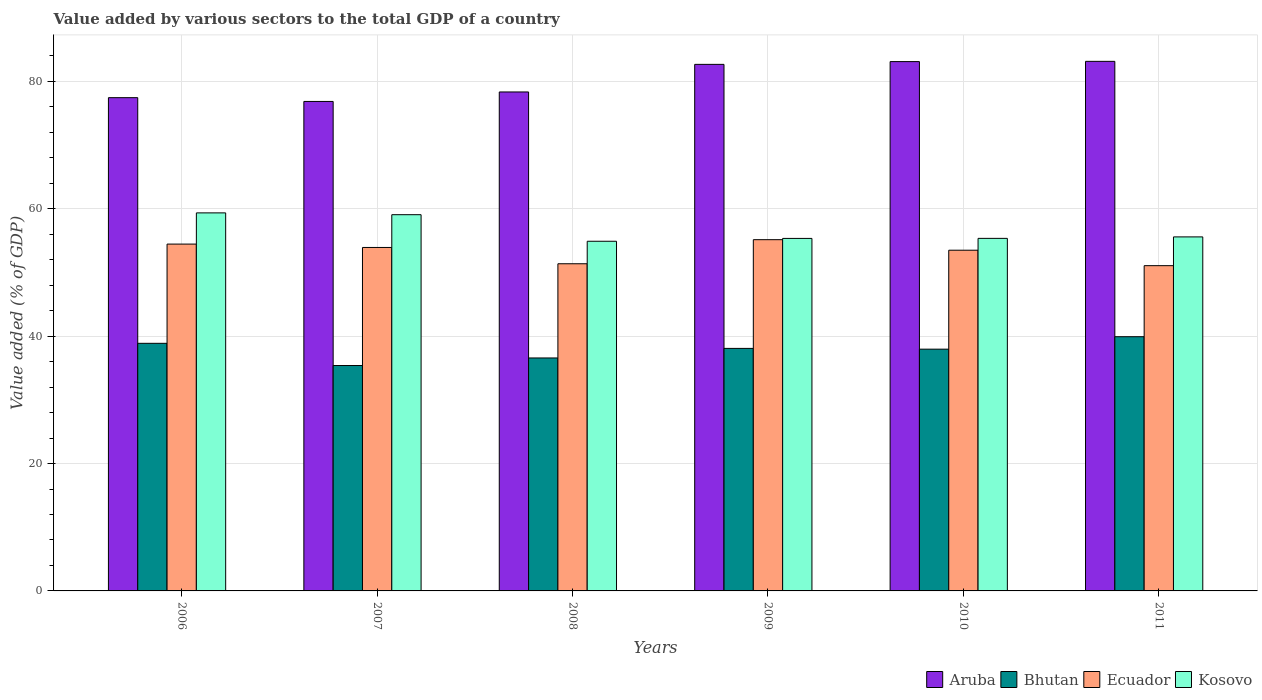Are the number of bars on each tick of the X-axis equal?
Provide a succinct answer. Yes. In how many cases, is the number of bars for a given year not equal to the number of legend labels?
Provide a succinct answer. 0. What is the value added by various sectors to the total GDP in Bhutan in 2008?
Make the answer very short. 36.58. Across all years, what is the maximum value added by various sectors to the total GDP in Bhutan?
Provide a short and direct response. 39.92. Across all years, what is the minimum value added by various sectors to the total GDP in Bhutan?
Provide a short and direct response. 35.39. In which year was the value added by various sectors to the total GDP in Kosovo maximum?
Your response must be concise. 2006. What is the total value added by various sectors to the total GDP in Ecuador in the graph?
Offer a terse response. 319.49. What is the difference between the value added by various sectors to the total GDP in Bhutan in 2006 and that in 2009?
Provide a succinct answer. 0.8. What is the difference between the value added by various sectors to the total GDP in Bhutan in 2008 and the value added by various sectors to the total GDP in Kosovo in 2006?
Provide a succinct answer. -22.78. What is the average value added by various sectors to the total GDP in Bhutan per year?
Provide a short and direct response. 37.8. In the year 2010, what is the difference between the value added by various sectors to the total GDP in Bhutan and value added by various sectors to the total GDP in Ecuador?
Give a very brief answer. -15.54. What is the ratio of the value added by various sectors to the total GDP in Aruba in 2007 to that in 2010?
Give a very brief answer. 0.92. Is the difference between the value added by various sectors to the total GDP in Bhutan in 2008 and 2010 greater than the difference between the value added by various sectors to the total GDP in Ecuador in 2008 and 2010?
Keep it short and to the point. Yes. What is the difference between the highest and the second highest value added by various sectors to the total GDP in Ecuador?
Keep it short and to the point. 0.69. What is the difference between the highest and the lowest value added by various sectors to the total GDP in Aruba?
Offer a terse response. 6.3. What does the 1st bar from the left in 2010 represents?
Your answer should be compact. Aruba. What does the 2nd bar from the right in 2009 represents?
Your answer should be compact. Ecuador. Is it the case that in every year, the sum of the value added by various sectors to the total GDP in Aruba and value added by various sectors to the total GDP in Ecuador is greater than the value added by various sectors to the total GDP in Bhutan?
Offer a terse response. Yes. How many bars are there?
Your response must be concise. 24. Are all the bars in the graph horizontal?
Your answer should be compact. No. How many years are there in the graph?
Give a very brief answer. 6. Does the graph contain any zero values?
Provide a short and direct response. No. How are the legend labels stacked?
Your answer should be compact. Horizontal. What is the title of the graph?
Provide a short and direct response. Value added by various sectors to the total GDP of a country. What is the label or title of the Y-axis?
Offer a very short reply. Value added (% of GDP). What is the Value added (% of GDP) in Aruba in 2006?
Your response must be concise. 77.45. What is the Value added (% of GDP) in Bhutan in 2006?
Your answer should be compact. 38.88. What is the Value added (% of GDP) in Ecuador in 2006?
Offer a terse response. 54.46. What is the Value added (% of GDP) of Kosovo in 2006?
Your answer should be compact. 59.36. What is the Value added (% of GDP) of Aruba in 2007?
Your response must be concise. 76.86. What is the Value added (% of GDP) of Bhutan in 2007?
Provide a succinct answer. 35.39. What is the Value added (% of GDP) in Ecuador in 2007?
Keep it short and to the point. 53.93. What is the Value added (% of GDP) in Kosovo in 2007?
Keep it short and to the point. 59.08. What is the Value added (% of GDP) in Aruba in 2008?
Your response must be concise. 78.35. What is the Value added (% of GDP) in Bhutan in 2008?
Ensure brevity in your answer.  36.58. What is the Value added (% of GDP) of Ecuador in 2008?
Provide a succinct answer. 51.37. What is the Value added (% of GDP) of Kosovo in 2008?
Ensure brevity in your answer.  54.91. What is the Value added (% of GDP) of Aruba in 2009?
Offer a terse response. 82.68. What is the Value added (% of GDP) in Bhutan in 2009?
Your answer should be very brief. 38.08. What is the Value added (% of GDP) in Ecuador in 2009?
Offer a terse response. 55.15. What is the Value added (% of GDP) in Kosovo in 2009?
Your answer should be very brief. 55.35. What is the Value added (% of GDP) of Aruba in 2010?
Give a very brief answer. 83.12. What is the Value added (% of GDP) of Bhutan in 2010?
Give a very brief answer. 37.96. What is the Value added (% of GDP) of Ecuador in 2010?
Provide a succinct answer. 53.5. What is the Value added (% of GDP) in Kosovo in 2010?
Your response must be concise. 55.36. What is the Value added (% of GDP) in Aruba in 2011?
Ensure brevity in your answer.  83.16. What is the Value added (% of GDP) in Bhutan in 2011?
Provide a short and direct response. 39.92. What is the Value added (% of GDP) of Ecuador in 2011?
Offer a terse response. 51.07. What is the Value added (% of GDP) in Kosovo in 2011?
Make the answer very short. 55.59. Across all years, what is the maximum Value added (% of GDP) in Aruba?
Keep it short and to the point. 83.16. Across all years, what is the maximum Value added (% of GDP) of Bhutan?
Make the answer very short. 39.92. Across all years, what is the maximum Value added (% of GDP) of Ecuador?
Make the answer very short. 55.15. Across all years, what is the maximum Value added (% of GDP) of Kosovo?
Offer a terse response. 59.36. Across all years, what is the minimum Value added (% of GDP) in Aruba?
Offer a very short reply. 76.86. Across all years, what is the minimum Value added (% of GDP) of Bhutan?
Make the answer very short. 35.39. Across all years, what is the minimum Value added (% of GDP) of Ecuador?
Ensure brevity in your answer.  51.07. Across all years, what is the minimum Value added (% of GDP) of Kosovo?
Provide a succinct answer. 54.91. What is the total Value added (% of GDP) of Aruba in the graph?
Your response must be concise. 481.62. What is the total Value added (% of GDP) in Bhutan in the graph?
Provide a short and direct response. 226.81. What is the total Value added (% of GDP) of Ecuador in the graph?
Offer a terse response. 319.49. What is the total Value added (% of GDP) in Kosovo in the graph?
Provide a succinct answer. 339.65. What is the difference between the Value added (% of GDP) in Aruba in 2006 and that in 2007?
Offer a terse response. 0.59. What is the difference between the Value added (% of GDP) of Bhutan in 2006 and that in 2007?
Give a very brief answer. 3.49. What is the difference between the Value added (% of GDP) of Ecuador in 2006 and that in 2007?
Your answer should be very brief. 0.53. What is the difference between the Value added (% of GDP) of Kosovo in 2006 and that in 2007?
Give a very brief answer. 0.28. What is the difference between the Value added (% of GDP) of Aruba in 2006 and that in 2008?
Your answer should be compact. -0.9. What is the difference between the Value added (% of GDP) of Bhutan in 2006 and that in 2008?
Provide a short and direct response. 2.3. What is the difference between the Value added (% of GDP) in Ecuador in 2006 and that in 2008?
Make the answer very short. 3.09. What is the difference between the Value added (% of GDP) of Kosovo in 2006 and that in 2008?
Your answer should be very brief. 4.46. What is the difference between the Value added (% of GDP) of Aruba in 2006 and that in 2009?
Provide a short and direct response. -5.23. What is the difference between the Value added (% of GDP) in Bhutan in 2006 and that in 2009?
Provide a succinct answer. 0.8. What is the difference between the Value added (% of GDP) in Ecuador in 2006 and that in 2009?
Your response must be concise. -0.69. What is the difference between the Value added (% of GDP) in Kosovo in 2006 and that in 2009?
Your response must be concise. 4.01. What is the difference between the Value added (% of GDP) of Aruba in 2006 and that in 2010?
Offer a very short reply. -5.66. What is the difference between the Value added (% of GDP) in Bhutan in 2006 and that in 2010?
Offer a very short reply. 0.92. What is the difference between the Value added (% of GDP) in Ecuador in 2006 and that in 2010?
Give a very brief answer. 0.96. What is the difference between the Value added (% of GDP) in Kosovo in 2006 and that in 2010?
Your response must be concise. 4. What is the difference between the Value added (% of GDP) of Aruba in 2006 and that in 2011?
Your answer should be very brief. -5.7. What is the difference between the Value added (% of GDP) of Bhutan in 2006 and that in 2011?
Offer a very short reply. -1.04. What is the difference between the Value added (% of GDP) in Ecuador in 2006 and that in 2011?
Make the answer very short. 3.39. What is the difference between the Value added (% of GDP) in Kosovo in 2006 and that in 2011?
Provide a short and direct response. 3.77. What is the difference between the Value added (% of GDP) in Aruba in 2007 and that in 2008?
Your answer should be very brief. -1.49. What is the difference between the Value added (% of GDP) in Bhutan in 2007 and that in 2008?
Make the answer very short. -1.19. What is the difference between the Value added (% of GDP) in Ecuador in 2007 and that in 2008?
Your response must be concise. 2.56. What is the difference between the Value added (% of GDP) of Kosovo in 2007 and that in 2008?
Offer a very short reply. 4.17. What is the difference between the Value added (% of GDP) of Aruba in 2007 and that in 2009?
Provide a succinct answer. -5.82. What is the difference between the Value added (% of GDP) of Bhutan in 2007 and that in 2009?
Your answer should be compact. -2.69. What is the difference between the Value added (% of GDP) in Ecuador in 2007 and that in 2009?
Provide a short and direct response. -1.22. What is the difference between the Value added (% of GDP) of Kosovo in 2007 and that in 2009?
Ensure brevity in your answer.  3.73. What is the difference between the Value added (% of GDP) of Aruba in 2007 and that in 2010?
Provide a succinct answer. -6.26. What is the difference between the Value added (% of GDP) in Bhutan in 2007 and that in 2010?
Give a very brief answer. -2.57. What is the difference between the Value added (% of GDP) in Ecuador in 2007 and that in 2010?
Keep it short and to the point. 0.43. What is the difference between the Value added (% of GDP) in Kosovo in 2007 and that in 2010?
Keep it short and to the point. 3.72. What is the difference between the Value added (% of GDP) of Aruba in 2007 and that in 2011?
Offer a very short reply. -6.3. What is the difference between the Value added (% of GDP) of Bhutan in 2007 and that in 2011?
Keep it short and to the point. -4.53. What is the difference between the Value added (% of GDP) in Ecuador in 2007 and that in 2011?
Your answer should be very brief. 2.86. What is the difference between the Value added (% of GDP) in Kosovo in 2007 and that in 2011?
Provide a short and direct response. 3.49. What is the difference between the Value added (% of GDP) of Aruba in 2008 and that in 2009?
Ensure brevity in your answer.  -4.33. What is the difference between the Value added (% of GDP) in Bhutan in 2008 and that in 2009?
Offer a very short reply. -1.5. What is the difference between the Value added (% of GDP) of Ecuador in 2008 and that in 2009?
Give a very brief answer. -3.78. What is the difference between the Value added (% of GDP) of Kosovo in 2008 and that in 2009?
Your response must be concise. -0.45. What is the difference between the Value added (% of GDP) of Aruba in 2008 and that in 2010?
Offer a very short reply. -4.77. What is the difference between the Value added (% of GDP) of Bhutan in 2008 and that in 2010?
Ensure brevity in your answer.  -1.38. What is the difference between the Value added (% of GDP) of Ecuador in 2008 and that in 2010?
Keep it short and to the point. -2.13. What is the difference between the Value added (% of GDP) in Kosovo in 2008 and that in 2010?
Provide a short and direct response. -0.45. What is the difference between the Value added (% of GDP) of Aruba in 2008 and that in 2011?
Your answer should be compact. -4.81. What is the difference between the Value added (% of GDP) of Bhutan in 2008 and that in 2011?
Ensure brevity in your answer.  -3.34. What is the difference between the Value added (% of GDP) in Ecuador in 2008 and that in 2011?
Offer a terse response. 0.3. What is the difference between the Value added (% of GDP) in Kosovo in 2008 and that in 2011?
Your answer should be compact. -0.68. What is the difference between the Value added (% of GDP) of Aruba in 2009 and that in 2010?
Offer a terse response. -0.44. What is the difference between the Value added (% of GDP) of Bhutan in 2009 and that in 2010?
Provide a succinct answer. 0.12. What is the difference between the Value added (% of GDP) in Ecuador in 2009 and that in 2010?
Your answer should be very brief. 1.65. What is the difference between the Value added (% of GDP) of Kosovo in 2009 and that in 2010?
Provide a short and direct response. -0.01. What is the difference between the Value added (% of GDP) of Aruba in 2009 and that in 2011?
Your answer should be very brief. -0.47. What is the difference between the Value added (% of GDP) in Bhutan in 2009 and that in 2011?
Offer a terse response. -1.83. What is the difference between the Value added (% of GDP) of Ecuador in 2009 and that in 2011?
Offer a terse response. 4.08. What is the difference between the Value added (% of GDP) of Kosovo in 2009 and that in 2011?
Your answer should be very brief. -0.24. What is the difference between the Value added (% of GDP) in Aruba in 2010 and that in 2011?
Provide a succinct answer. -0.04. What is the difference between the Value added (% of GDP) in Bhutan in 2010 and that in 2011?
Provide a succinct answer. -1.96. What is the difference between the Value added (% of GDP) in Ecuador in 2010 and that in 2011?
Make the answer very short. 2.43. What is the difference between the Value added (% of GDP) of Kosovo in 2010 and that in 2011?
Keep it short and to the point. -0.23. What is the difference between the Value added (% of GDP) of Aruba in 2006 and the Value added (% of GDP) of Bhutan in 2007?
Give a very brief answer. 42.06. What is the difference between the Value added (% of GDP) in Aruba in 2006 and the Value added (% of GDP) in Ecuador in 2007?
Provide a short and direct response. 23.52. What is the difference between the Value added (% of GDP) of Aruba in 2006 and the Value added (% of GDP) of Kosovo in 2007?
Your answer should be compact. 18.37. What is the difference between the Value added (% of GDP) of Bhutan in 2006 and the Value added (% of GDP) of Ecuador in 2007?
Give a very brief answer. -15.05. What is the difference between the Value added (% of GDP) of Bhutan in 2006 and the Value added (% of GDP) of Kosovo in 2007?
Ensure brevity in your answer.  -20.2. What is the difference between the Value added (% of GDP) in Ecuador in 2006 and the Value added (% of GDP) in Kosovo in 2007?
Offer a very short reply. -4.62. What is the difference between the Value added (% of GDP) in Aruba in 2006 and the Value added (% of GDP) in Bhutan in 2008?
Your answer should be very brief. 40.87. What is the difference between the Value added (% of GDP) of Aruba in 2006 and the Value added (% of GDP) of Ecuador in 2008?
Your answer should be compact. 26.08. What is the difference between the Value added (% of GDP) of Aruba in 2006 and the Value added (% of GDP) of Kosovo in 2008?
Offer a very short reply. 22.55. What is the difference between the Value added (% of GDP) in Bhutan in 2006 and the Value added (% of GDP) in Ecuador in 2008?
Give a very brief answer. -12.49. What is the difference between the Value added (% of GDP) of Bhutan in 2006 and the Value added (% of GDP) of Kosovo in 2008?
Provide a short and direct response. -16.03. What is the difference between the Value added (% of GDP) of Ecuador in 2006 and the Value added (% of GDP) of Kosovo in 2008?
Your answer should be very brief. -0.44. What is the difference between the Value added (% of GDP) in Aruba in 2006 and the Value added (% of GDP) in Bhutan in 2009?
Give a very brief answer. 39.37. What is the difference between the Value added (% of GDP) of Aruba in 2006 and the Value added (% of GDP) of Ecuador in 2009?
Your response must be concise. 22.3. What is the difference between the Value added (% of GDP) in Aruba in 2006 and the Value added (% of GDP) in Kosovo in 2009?
Your answer should be compact. 22.1. What is the difference between the Value added (% of GDP) in Bhutan in 2006 and the Value added (% of GDP) in Ecuador in 2009?
Your answer should be very brief. -16.27. What is the difference between the Value added (% of GDP) of Bhutan in 2006 and the Value added (% of GDP) of Kosovo in 2009?
Ensure brevity in your answer.  -16.47. What is the difference between the Value added (% of GDP) of Ecuador in 2006 and the Value added (% of GDP) of Kosovo in 2009?
Your answer should be compact. -0.89. What is the difference between the Value added (% of GDP) of Aruba in 2006 and the Value added (% of GDP) of Bhutan in 2010?
Your answer should be very brief. 39.49. What is the difference between the Value added (% of GDP) of Aruba in 2006 and the Value added (% of GDP) of Ecuador in 2010?
Provide a short and direct response. 23.95. What is the difference between the Value added (% of GDP) of Aruba in 2006 and the Value added (% of GDP) of Kosovo in 2010?
Keep it short and to the point. 22.09. What is the difference between the Value added (% of GDP) of Bhutan in 2006 and the Value added (% of GDP) of Ecuador in 2010?
Provide a succinct answer. -14.62. What is the difference between the Value added (% of GDP) of Bhutan in 2006 and the Value added (% of GDP) of Kosovo in 2010?
Ensure brevity in your answer.  -16.48. What is the difference between the Value added (% of GDP) in Ecuador in 2006 and the Value added (% of GDP) in Kosovo in 2010?
Ensure brevity in your answer.  -0.9. What is the difference between the Value added (% of GDP) in Aruba in 2006 and the Value added (% of GDP) in Bhutan in 2011?
Make the answer very short. 37.54. What is the difference between the Value added (% of GDP) of Aruba in 2006 and the Value added (% of GDP) of Ecuador in 2011?
Give a very brief answer. 26.38. What is the difference between the Value added (% of GDP) in Aruba in 2006 and the Value added (% of GDP) in Kosovo in 2011?
Your answer should be very brief. 21.86. What is the difference between the Value added (% of GDP) of Bhutan in 2006 and the Value added (% of GDP) of Ecuador in 2011?
Your answer should be compact. -12.19. What is the difference between the Value added (% of GDP) in Bhutan in 2006 and the Value added (% of GDP) in Kosovo in 2011?
Your answer should be compact. -16.71. What is the difference between the Value added (% of GDP) of Ecuador in 2006 and the Value added (% of GDP) of Kosovo in 2011?
Make the answer very short. -1.13. What is the difference between the Value added (% of GDP) in Aruba in 2007 and the Value added (% of GDP) in Bhutan in 2008?
Provide a succinct answer. 40.28. What is the difference between the Value added (% of GDP) in Aruba in 2007 and the Value added (% of GDP) in Ecuador in 2008?
Your answer should be compact. 25.49. What is the difference between the Value added (% of GDP) of Aruba in 2007 and the Value added (% of GDP) of Kosovo in 2008?
Give a very brief answer. 21.95. What is the difference between the Value added (% of GDP) of Bhutan in 2007 and the Value added (% of GDP) of Ecuador in 2008?
Offer a very short reply. -15.98. What is the difference between the Value added (% of GDP) of Bhutan in 2007 and the Value added (% of GDP) of Kosovo in 2008?
Your answer should be compact. -19.51. What is the difference between the Value added (% of GDP) of Ecuador in 2007 and the Value added (% of GDP) of Kosovo in 2008?
Offer a very short reply. -0.98. What is the difference between the Value added (% of GDP) of Aruba in 2007 and the Value added (% of GDP) of Bhutan in 2009?
Keep it short and to the point. 38.78. What is the difference between the Value added (% of GDP) of Aruba in 2007 and the Value added (% of GDP) of Ecuador in 2009?
Offer a very short reply. 21.71. What is the difference between the Value added (% of GDP) of Aruba in 2007 and the Value added (% of GDP) of Kosovo in 2009?
Make the answer very short. 21.51. What is the difference between the Value added (% of GDP) of Bhutan in 2007 and the Value added (% of GDP) of Ecuador in 2009?
Offer a very short reply. -19.76. What is the difference between the Value added (% of GDP) of Bhutan in 2007 and the Value added (% of GDP) of Kosovo in 2009?
Make the answer very short. -19.96. What is the difference between the Value added (% of GDP) in Ecuador in 2007 and the Value added (% of GDP) in Kosovo in 2009?
Your response must be concise. -1.42. What is the difference between the Value added (% of GDP) in Aruba in 2007 and the Value added (% of GDP) in Bhutan in 2010?
Your answer should be compact. 38.9. What is the difference between the Value added (% of GDP) in Aruba in 2007 and the Value added (% of GDP) in Ecuador in 2010?
Your answer should be very brief. 23.36. What is the difference between the Value added (% of GDP) in Aruba in 2007 and the Value added (% of GDP) in Kosovo in 2010?
Offer a very short reply. 21.5. What is the difference between the Value added (% of GDP) in Bhutan in 2007 and the Value added (% of GDP) in Ecuador in 2010?
Make the answer very short. -18.11. What is the difference between the Value added (% of GDP) in Bhutan in 2007 and the Value added (% of GDP) in Kosovo in 2010?
Your answer should be very brief. -19.97. What is the difference between the Value added (% of GDP) of Ecuador in 2007 and the Value added (% of GDP) of Kosovo in 2010?
Ensure brevity in your answer.  -1.43. What is the difference between the Value added (% of GDP) of Aruba in 2007 and the Value added (% of GDP) of Bhutan in 2011?
Ensure brevity in your answer.  36.94. What is the difference between the Value added (% of GDP) in Aruba in 2007 and the Value added (% of GDP) in Ecuador in 2011?
Give a very brief answer. 25.79. What is the difference between the Value added (% of GDP) in Aruba in 2007 and the Value added (% of GDP) in Kosovo in 2011?
Provide a short and direct response. 21.27. What is the difference between the Value added (% of GDP) in Bhutan in 2007 and the Value added (% of GDP) in Ecuador in 2011?
Offer a very short reply. -15.68. What is the difference between the Value added (% of GDP) of Bhutan in 2007 and the Value added (% of GDP) of Kosovo in 2011?
Offer a very short reply. -20.2. What is the difference between the Value added (% of GDP) in Ecuador in 2007 and the Value added (% of GDP) in Kosovo in 2011?
Your answer should be compact. -1.66. What is the difference between the Value added (% of GDP) in Aruba in 2008 and the Value added (% of GDP) in Bhutan in 2009?
Offer a terse response. 40.27. What is the difference between the Value added (% of GDP) of Aruba in 2008 and the Value added (% of GDP) of Ecuador in 2009?
Keep it short and to the point. 23.2. What is the difference between the Value added (% of GDP) in Aruba in 2008 and the Value added (% of GDP) in Kosovo in 2009?
Your answer should be very brief. 23. What is the difference between the Value added (% of GDP) in Bhutan in 2008 and the Value added (% of GDP) in Ecuador in 2009?
Provide a short and direct response. -18.57. What is the difference between the Value added (% of GDP) in Bhutan in 2008 and the Value added (% of GDP) in Kosovo in 2009?
Your answer should be very brief. -18.77. What is the difference between the Value added (% of GDP) of Ecuador in 2008 and the Value added (% of GDP) of Kosovo in 2009?
Your answer should be compact. -3.98. What is the difference between the Value added (% of GDP) of Aruba in 2008 and the Value added (% of GDP) of Bhutan in 2010?
Provide a short and direct response. 40.39. What is the difference between the Value added (% of GDP) of Aruba in 2008 and the Value added (% of GDP) of Ecuador in 2010?
Offer a very short reply. 24.85. What is the difference between the Value added (% of GDP) of Aruba in 2008 and the Value added (% of GDP) of Kosovo in 2010?
Your response must be concise. 22.99. What is the difference between the Value added (% of GDP) of Bhutan in 2008 and the Value added (% of GDP) of Ecuador in 2010?
Keep it short and to the point. -16.92. What is the difference between the Value added (% of GDP) in Bhutan in 2008 and the Value added (% of GDP) in Kosovo in 2010?
Keep it short and to the point. -18.78. What is the difference between the Value added (% of GDP) of Ecuador in 2008 and the Value added (% of GDP) of Kosovo in 2010?
Your answer should be compact. -3.99. What is the difference between the Value added (% of GDP) in Aruba in 2008 and the Value added (% of GDP) in Bhutan in 2011?
Keep it short and to the point. 38.43. What is the difference between the Value added (% of GDP) in Aruba in 2008 and the Value added (% of GDP) in Ecuador in 2011?
Make the answer very short. 27.28. What is the difference between the Value added (% of GDP) of Aruba in 2008 and the Value added (% of GDP) of Kosovo in 2011?
Your response must be concise. 22.76. What is the difference between the Value added (% of GDP) in Bhutan in 2008 and the Value added (% of GDP) in Ecuador in 2011?
Give a very brief answer. -14.49. What is the difference between the Value added (% of GDP) of Bhutan in 2008 and the Value added (% of GDP) of Kosovo in 2011?
Give a very brief answer. -19.01. What is the difference between the Value added (% of GDP) of Ecuador in 2008 and the Value added (% of GDP) of Kosovo in 2011?
Your answer should be very brief. -4.22. What is the difference between the Value added (% of GDP) in Aruba in 2009 and the Value added (% of GDP) in Bhutan in 2010?
Your answer should be very brief. 44.72. What is the difference between the Value added (% of GDP) in Aruba in 2009 and the Value added (% of GDP) in Ecuador in 2010?
Offer a very short reply. 29.18. What is the difference between the Value added (% of GDP) in Aruba in 2009 and the Value added (% of GDP) in Kosovo in 2010?
Make the answer very short. 27.32. What is the difference between the Value added (% of GDP) in Bhutan in 2009 and the Value added (% of GDP) in Ecuador in 2010?
Offer a very short reply. -15.42. What is the difference between the Value added (% of GDP) of Bhutan in 2009 and the Value added (% of GDP) of Kosovo in 2010?
Provide a succinct answer. -17.28. What is the difference between the Value added (% of GDP) of Ecuador in 2009 and the Value added (% of GDP) of Kosovo in 2010?
Keep it short and to the point. -0.21. What is the difference between the Value added (% of GDP) of Aruba in 2009 and the Value added (% of GDP) of Bhutan in 2011?
Provide a short and direct response. 42.76. What is the difference between the Value added (% of GDP) in Aruba in 2009 and the Value added (% of GDP) in Ecuador in 2011?
Make the answer very short. 31.61. What is the difference between the Value added (% of GDP) of Aruba in 2009 and the Value added (% of GDP) of Kosovo in 2011?
Your response must be concise. 27.09. What is the difference between the Value added (% of GDP) in Bhutan in 2009 and the Value added (% of GDP) in Ecuador in 2011?
Give a very brief answer. -12.99. What is the difference between the Value added (% of GDP) of Bhutan in 2009 and the Value added (% of GDP) of Kosovo in 2011?
Give a very brief answer. -17.51. What is the difference between the Value added (% of GDP) of Ecuador in 2009 and the Value added (% of GDP) of Kosovo in 2011?
Ensure brevity in your answer.  -0.44. What is the difference between the Value added (% of GDP) of Aruba in 2010 and the Value added (% of GDP) of Bhutan in 2011?
Give a very brief answer. 43.2. What is the difference between the Value added (% of GDP) of Aruba in 2010 and the Value added (% of GDP) of Ecuador in 2011?
Keep it short and to the point. 32.04. What is the difference between the Value added (% of GDP) of Aruba in 2010 and the Value added (% of GDP) of Kosovo in 2011?
Offer a terse response. 27.53. What is the difference between the Value added (% of GDP) in Bhutan in 2010 and the Value added (% of GDP) in Ecuador in 2011?
Provide a succinct answer. -13.11. What is the difference between the Value added (% of GDP) of Bhutan in 2010 and the Value added (% of GDP) of Kosovo in 2011?
Your answer should be very brief. -17.63. What is the difference between the Value added (% of GDP) in Ecuador in 2010 and the Value added (% of GDP) in Kosovo in 2011?
Keep it short and to the point. -2.09. What is the average Value added (% of GDP) of Aruba per year?
Give a very brief answer. 80.27. What is the average Value added (% of GDP) of Bhutan per year?
Offer a very short reply. 37.8. What is the average Value added (% of GDP) of Ecuador per year?
Ensure brevity in your answer.  53.25. What is the average Value added (% of GDP) of Kosovo per year?
Your response must be concise. 56.61. In the year 2006, what is the difference between the Value added (% of GDP) in Aruba and Value added (% of GDP) in Bhutan?
Keep it short and to the point. 38.57. In the year 2006, what is the difference between the Value added (% of GDP) of Aruba and Value added (% of GDP) of Ecuador?
Keep it short and to the point. 22.99. In the year 2006, what is the difference between the Value added (% of GDP) in Aruba and Value added (% of GDP) in Kosovo?
Provide a succinct answer. 18.09. In the year 2006, what is the difference between the Value added (% of GDP) of Bhutan and Value added (% of GDP) of Ecuador?
Keep it short and to the point. -15.58. In the year 2006, what is the difference between the Value added (% of GDP) of Bhutan and Value added (% of GDP) of Kosovo?
Offer a terse response. -20.48. In the year 2006, what is the difference between the Value added (% of GDP) of Ecuador and Value added (% of GDP) of Kosovo?
Make the answer very short. -4.9. In the year 2007, what is the difference between the Value added (% of GDP) in Aruba and Value added (% of GDP) in Bhutan?
Ensure brevity in your answer.  41.47. In the year 2007, what is the difference between the Value added (% of GDP) of Aruba and Value added (% of GDP) of Ecuador?
Your response must be concise. 22.93. In the year 2007, what is the difference between the Value added (% of GDP) of Aruba and Value added (% of GDP) of Kosovo?
Make the answer very short. 17.78. In the year 2007, what is the difference between the Value added (% of GDP) in Bhutan and Value added (% of GDP) in Ecuador?
Make the answer very short. -18.54. In the year 2007, what is the difference between the Value added (% of GDP) of Bhutan and Value added (% of GDP) of Kosovo?
Offer a terse response. -23.69. In the year 2007, what is the difference between the Value added (% of GDP) of Ecuador and Value added (% of GDP) of Kosovo?
Offer a very short reply. -5.15. In the year 2008, what is the difference between the Value added (% of GDP) of Aruba and Value added (% of GDP) of Bhutan?
Your answer should be compact. 41.77. In the year 2008, what is the difference between the Value added (% of GDP) in Aruba and Value added (% of GDP) in Ecuador?
Your answer should be very brief. 26.98. In the year 2008, what is the difference between the Value added (% of GDP) in Aruba and Value added (% of GDP) in Kosovo?
Give a very brief answer. 23.44. In the year 2008, what is the difference between the Value added (% of GDP) in Bhutan and Value added (% of GDP) in Ecuador?
Keep it short and to the point. -14.79. In the year 2008, what is the difference between the Value added (% of GDP) in Bhutan and Value added (% of GDP) in Kosovo?
Offer a terse response. -18.33. In the year 2008, what is the difference between the Value added (% of GDP) of Ecuador and Value added (% of GDP) of Kosovo?
Your answer should be compact. -3.53. In the year 2009, what is the difference between the Value added (% of GDP) in Aruba and Value added (% of GDP) in Bhutan?
Your response must be concise. 44.6. In the year 2009, what is the difference between the Value added (% of GDP) of Aruba and Value added (% of GDP) of Ecuador?
Your answer should be compact. 27.53. In the year 2009, what is the difference between the Value added (% of GDP) in Aruba and Value added (% of GDP) in Kosovo?
Your answer should be compact. 27.33. In the year 2009, what is the difference between the Value added (% of GDP) of Bhutan and Value added (% of GDP) of Ecuador?
Give a very brief answer. -17.07. In the year 2009, what is the difference between the Value added (% of GDP) of Bhutan and Value added (% of GDP) of Kosovo?
Ensure brevity in your answer.  -17.27. In the year 2009, what is the difference between the Value added (% of GDP) in Ecuador and Value added (% of GDP) in Kosovo?
Offer a terse response. -0.2. In the year 2010, what is the difference between the Value added (% of GDP) of Aruba and Value added (% of GDP) of Bhutan?
Keep it short and to the point. 45.15. In the year 2010, what is the difference between the Value added (% of GDP) of Aruba and Value added (% of GDP) of Ecuador?
Keep it short and to the point. 29.62. In the year 2010, what is the difference between the Value added (% of GDP) in Aruba and Value added (% of GDP) in Kosovo?
Offer a terse response. 27.76. In the year 2010, what is the difference between the Value added (% of GDP) in Bhutan and Value added (% of GDP) in Ecuador?
Your answer should be very brief. -15.54. In the year 2010, what is the difference between the Value added (% of GDP) in Bhutan and Value added (% of GDP) in Kosovo?
Make the answer very short. -17.4. In the year 2010, what is the difference between the Value added (% of GDP) of Ecuador and Value added (% of GDP) of Kosovo?
Offer a terse response. -1.86. In the year 2011, what is the difference between the Value added (% of GDP) of Aruba and Value added (% of GDP) of Bhutan?
Provide a short and direct response. 43.24. In the year 2011, what is the difference between the Value added (% of GDP) in Aruba and Value added (% of GDP) in Ecuador?
Provide a succinct answer. 32.08. In the year 2011, what is the difference between the Value added (% of GDP) of Aruba and Value added (% of GDP) of Kosovo?
Offer a terse response. 27.56. In the year 2011, what is the difference between the Value added (% of GDP) of Bhutan and Value added (% of GDP) of Ecuador?
Give a very brief answer. -11.16. In the year 2011, what is the difference between the Value added (% of GDP) of Bhutan and Value added (% of GDP) of Kosovo?
Give a very brief answer. -15.67. In the year 2011, what is the difference between the Value added (% of GDP) in Ecuador and Value added (% of GDP) in Kosovo?
Provide a succinct answer. -4.52. What is the ratio of the Value added (% of GDP) in Aruba in 2006 to that in 2007?
Your answer should be compact. 1.01. What is the ratio of the Value added (% of GDP) in Bhutan in 2006 to that in 2007?
Your answer should be compact. 1.1. What is the ratio of the Value added (% of GDP) in Ecuador in 2006 to that in 2007?
Provide a short and direct response. 1.01. What is the ratio of the Value added (% of GDP) in Bhutan in 2006 to that in 2008?
Your response must be concise. 1.06. What is the ratio of the Value added (% of GDP) in Ecuador in 2006 to that in 2008?
Your response must be concise. 1.06. What is the ratio of the Value added (% of GDP) of Kosovo in 2006 to that in 2008?
Give a very brief answer. 1.08. What is the ratio of the Value added (% of GDP) of Aruba in 2006 to that in 2009?
Your answer should be very brief. 0.94. What is the ratio of the Value added (% of GDP) in Bhutan in 2006 to that in 2009?
Offer a terse response. 1.02. What is the ratio of the Value added (% of GDP) of Ecuador in 2006 to that in 2009?
Provide a succinct answer. 0.99. What is the ratio of the Value added (% of GDP) of Kosovo in 2006 to that in 2009?
Your response must be concise. 1.07. What is the ratio of the Value added (% of GDP) in Aruba in 2006 to that in 2010?
Provide a succinct answer. 0.93. What is the ratio of the Value added (% of GDP) in Bhutan in 2006 to that in 2010?
Your answer should be very brief. 1.02. What is the ratio of the Value added (% of GDP) in Kosovo in 2006 to that in 2010?
Provide a succinct answer. 1.07. What is the ratio of the Value added (% of GDP) in Aruba in 2006 to that in 2011?
Keep it short and to the point. 0.93. What is the ratio of the Value added (% of GDP) in Ecuador in 2006 to that in 2011?
Keep it short and to the point. 1.07. What is the ratio of the Value added (% of GDP) of Kosovo in 2006 to that in 2011?
Your answer should be compact. 1.07. What is the ratio of the Value added (% of GDP) of Bhutan in 2007 to that in 2008?
Your answer should be compact. 0.97. What is the ratio of the Value added (% of GDP) in Ecuador in 2007 to that in 2008?
Offer a terse response. 1.05. What is the ratio of the Value added (% of GDP) of Kosovo in 2007 to that in 2008?
Give a very brief answer. 1.08. What is the ratio of the Value added (% of GDP) of Aruba in 2007 to that in 2009?
Your answer should be very brief. 0.93. What is the ratio of the Value added (% of GDP) in Bhutan in 2007 to that in 2009?
Your answer should be very brief. 0.93. What is the ratio of the Value added (% of GDP) of Ecuador in 2007 to that in 2009?
Offer a terse response. 0.98. What is the ratio of the Value added (% of GDP) in Kosovo in 2007 to that in 2009?
Give a very brief answer. 1.07. What is the ratio of the Value added (% of GDP) in Aruba in 2007 to that in 2010?
Your response must be concise. 0.92. What is the ratio of the Value added (% of GDP) of Bhutan in 2007 to that in 2010?
Your answer should be compact. 0.93. What is the ratio of the Value added (% of GDP) of Ecuador in 2007 to that in 2010?
Provide a succinct answer. 1.01. What is the ratio of the Value added (% of GDP) of Kosovo in 2007 to that in 2010?
Provide a short and direct response. 1.07. What is the ratio of the Value added (% of GDP) in Aruba in 2007 to that in 2011?
Your answer should be compact. 0.92. What is the ratio of the Value added (% of GDP) in Bhutan in 2007 to that in 2011?
Your response must be concise. 0.89. What is the ratio of the Value added (% of GDP) of Ecuador in 2007 to that in 2011?
Your answer should be compact. 1.06. What is the ratio of the Value added (% of GDP) of Kosovo in 2007 to that in 2011?
Your answer should be compact. 1.06. What is the ratio of the Value added (% of GDP) in Aruba in 2008 to that in 2009?
Your response must be concise. 0.95. What is the ratio of the Value added (% of GDP) of Bhutan in 2008 to that in 2009?
Offer a very short reply. 0.96. What is the ratio of the Value added (% of GDP) of Ecuador in 2008 to that in 2009?
Provide a succinct answer. 0.93. What is the ratio of the Value added (% of GDP) in Kosovo in 2008 to that in 2009?
Give a very brief answer. 0.99. What is the ratio of the Value added (% of GDP) of Aruba in 2008 to that in 2010?
Ensure brevity in your answer.  0.94. What is the ratio of the Value added (% of GDP) in Bhutan in 2008 to that in 2010?
Your response must be concise. 0.96. What is the ratio of the Value added (% of GDP) in Ecuador in 2008 to that in 2010?
Provide a short and direct response. 0.96. What is the ratio of the Value added (% of GDP) in Kosovo in 2008 to that in 2010?
Provide a short and direct response. 0.99. What is the ratio of the Value added (% of GDP) in Aruba in 2008 to that in 2011?
Your answer should be compact. 0.94. What is the ratio of the Value added (% of GDP) of Bhutan in 2008 to that in 2011?
Provide a short and direct response. 0.92. What is the ratio of the Value added (% of GDP) of Ecuador in 2008 to that in 2011?
Ensure brevity in your answer.  1.01. What is the ratio of the Value added (% of GDP) in Ecuador in 2009 to that in 2010?
Keep it short and to the point. 1.03. What is the ratio of the Value added (% of GDP) of Kosovo in 2009 to that in 2010?
Your response must be concise. 1. What is the ratio of the Value added (% of GDP) of Aruba in 2009 to that in 2011?
Offer a terse response. 0.99. What is the ratio of the Value added (% of GDP) of Bhutan in 2009 to that in 2011?
Keep it short and to the point. 0.95. What is the ratio of the Value added (% of GDP) in Ecuador in 2009 to that in 2011?
Give a very brief answer. 1.08. What is the ratio of the Value added (% of GDP) in Kosovo in 2009 to that in 2011?
Offer a terse response. 1. What is the ratio of the Value added (% of GDP) of Aruba in 2010 to that in 2011?
Provide a short and direct response. 1. What is the ratio of the Value added (% of GDP) in Bhutan in 2010 to that in 2011?
Your answer should be compact. 0.95. What is the ratio of the Value added (% of GDP) in Ecuador in 2010 to that in 2011?
Provide a short and direct response. 1.05. What is the ratio of the Value added (% of GDP) in Kosovo in 2010 to that in 2011?
Keep it short and to the point. 1. What is the difference between the highest and the second highest Value added (% of GDP) of Aruba?
Offer a very short reply. 0.04. What is the difference between the highest and the second highest Value added (% of GDP) in Bhutan?
Provide a succinct answer. 1.04. What is the difference between the highest and the second highest Value added (% of GDP) of Ecuador?
Your answer should be very brief. 0.69. What is the difference between the highest and the second highest Value added (% of GDP) of Kosovo?
Your answer should be compact. 0.28. What is the difference between the highest and the lowest Value added (% of GDP) in Aruba?
Provide a succinct answer. 6.3. What is the difference between the highest and the lowest Value added (% of GDP) of Bhutan?
Keep it short and to the point. 4.53. What is the difference between the highest and the lowest Value added (% of GDP) in Ecuador?
Make the answer very short. 4.08. What is the difference between the highest and the lowest Value added (% of GDP) of Kosovo?
Offer a terse response. 4.46. 